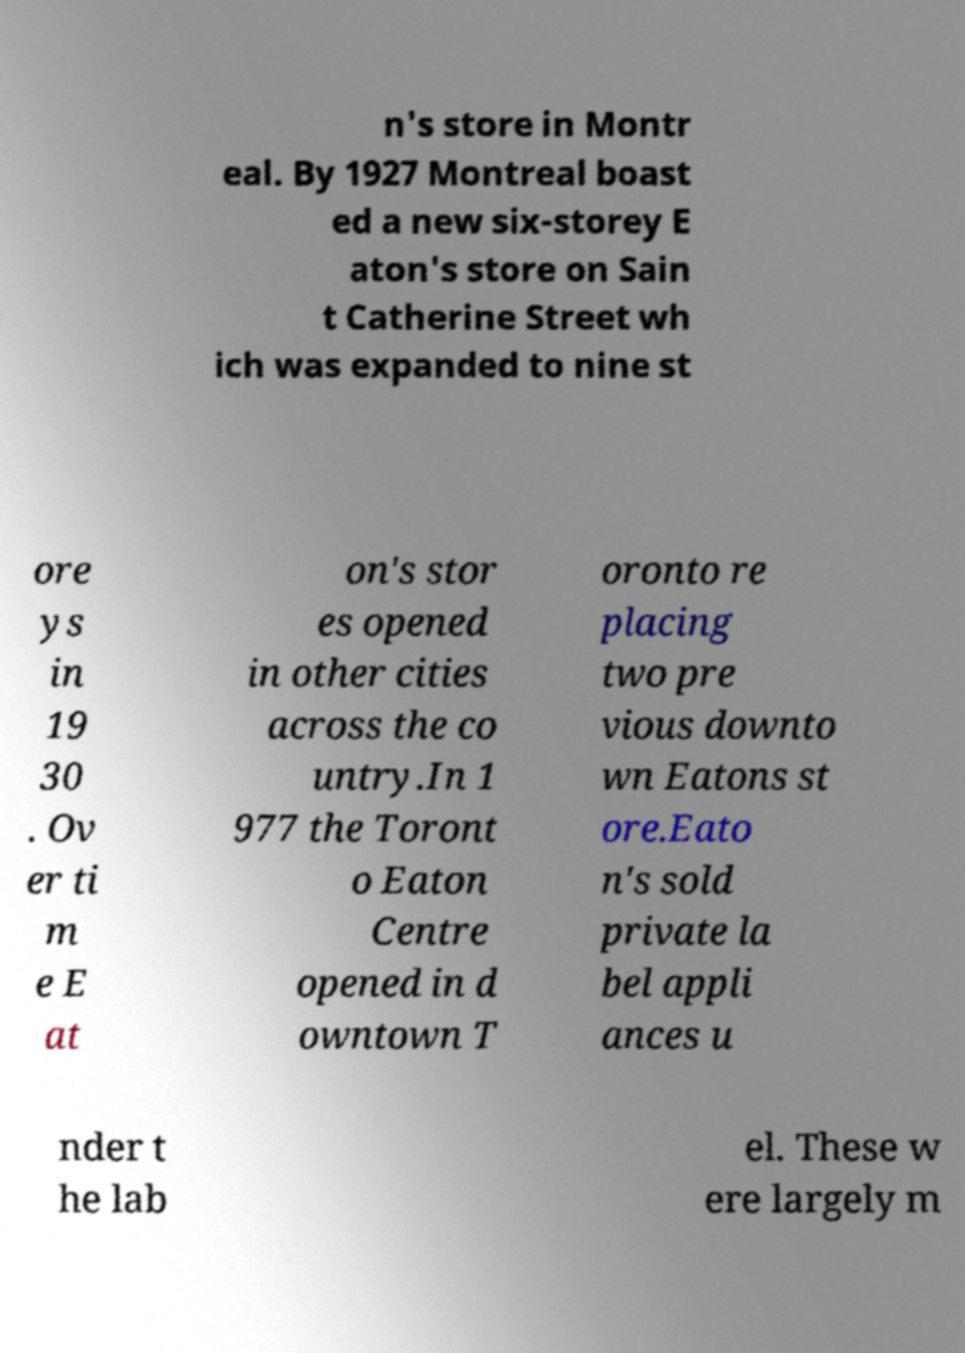I need the written content from this picture converted into text. Can you do that? n's store in Montr eal. By 1927 Montreal boast ed a new six-storey E aton's store on Sain t Catherine Street wh ich was expanded to nine st ore ys in 19 30 . Ov er ti m e E at on's stor es opened in other cities across the co untry.In 1 977 the Toront o Eaton Centre opened in d owntown T oronto re placing two pre vious downto wn Eatons st ore.Eato n's sold private la bel appli ances u nder t he lab el. These w ere largely m 